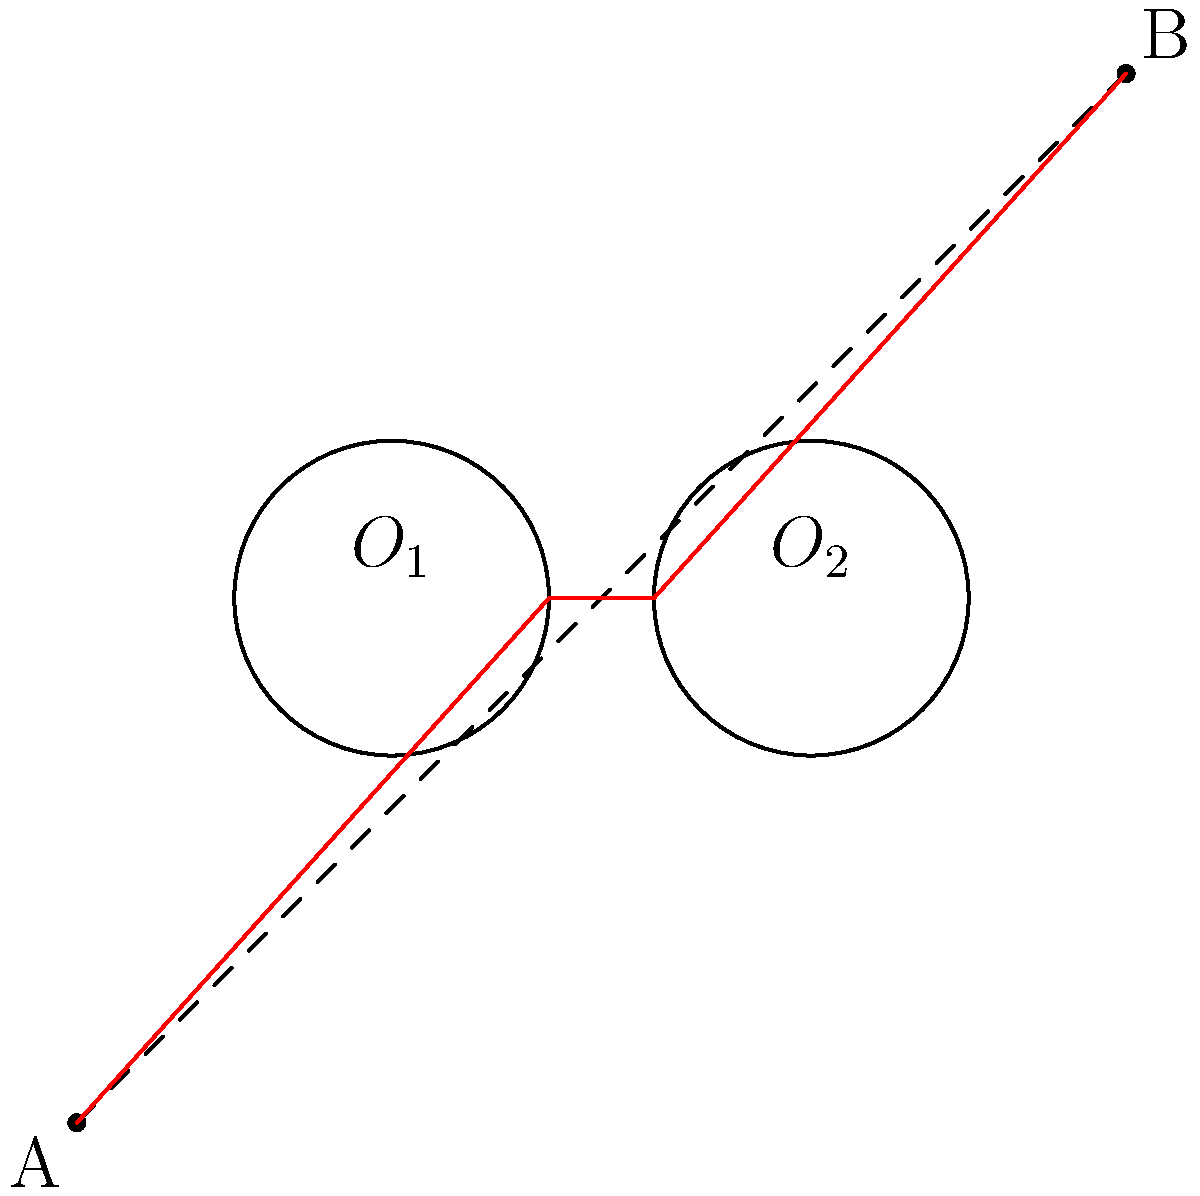In a 2D plane, two circular obstacles with centers $O_1(3,5)$ and $O_2(7,5)$ and equal radii of 1.5 units are present. Find the shortest path from point $A(0,0)$ to point $B(10,10)$ that avoids these obstacles. How does this problem relate to pathfinding in AI-driven game characters? 1. Visualize the problem: The direct path A to B intersects both obstacles.

2. Recognize the shortest path principle: The path must be a straight line except where it touches the obstacles.

3. Identify tangent points: The shortest path will be tangent to both circles.

4. Construct the path: 
   a. Draw a line from A tangent to the first circle.
   b. Draw a line tangent to both circles.
   c. Draw a line from the second circle tangent to B.

5. The path is: A → tangent point on $O_1$ → tangent point on $O_2$ → B

6. Calculate the length:
   Length = $\sqrt{(3-1.5)^2 + 5^2} + (7-3) + \sqrt{(10-7)^2 + (10-6.5)^2}$

7. Relation to AI pathfinding:
   - Represents obstacle avoidance in game environments.
   - Demonstrates the need for efficient algorithms (e.g., A*) in real-time rendering.
   - Illustrates the balance between optimal paths and computational efficiency.
   - Shows how geometric principles apply to AI decision-making in spatial contexts.
Answer: A → tangent($O_1$) → tangent($O_2$) → B; applies to AI pathfinding through obstacle avoidance, algorithm efficiency, and spatial decision-making. 